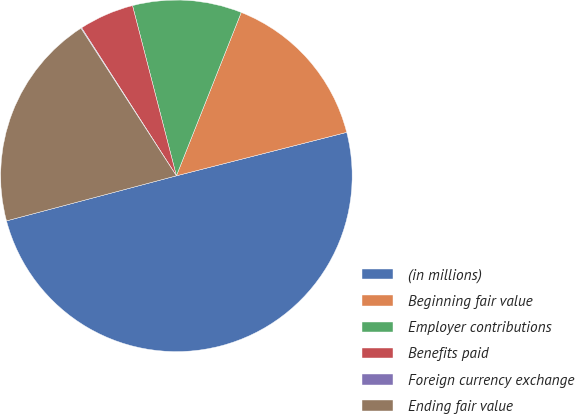Convert chart. <chart><loc_0><loc_0><loc_500><loc_500><pie_chart><fcel>(in millions)<fcel>Beginning fair value<fcel>Employer contributions<fcel>Benefits paid<fcel>Foreign currency exchange<fcel>Ending fair value<nl><fcel>49.85%<fcel>15.01%<fcel>10.03%<fcel>5.05%<fcel>0.07%<fcel>19.99%<nl></chart> 